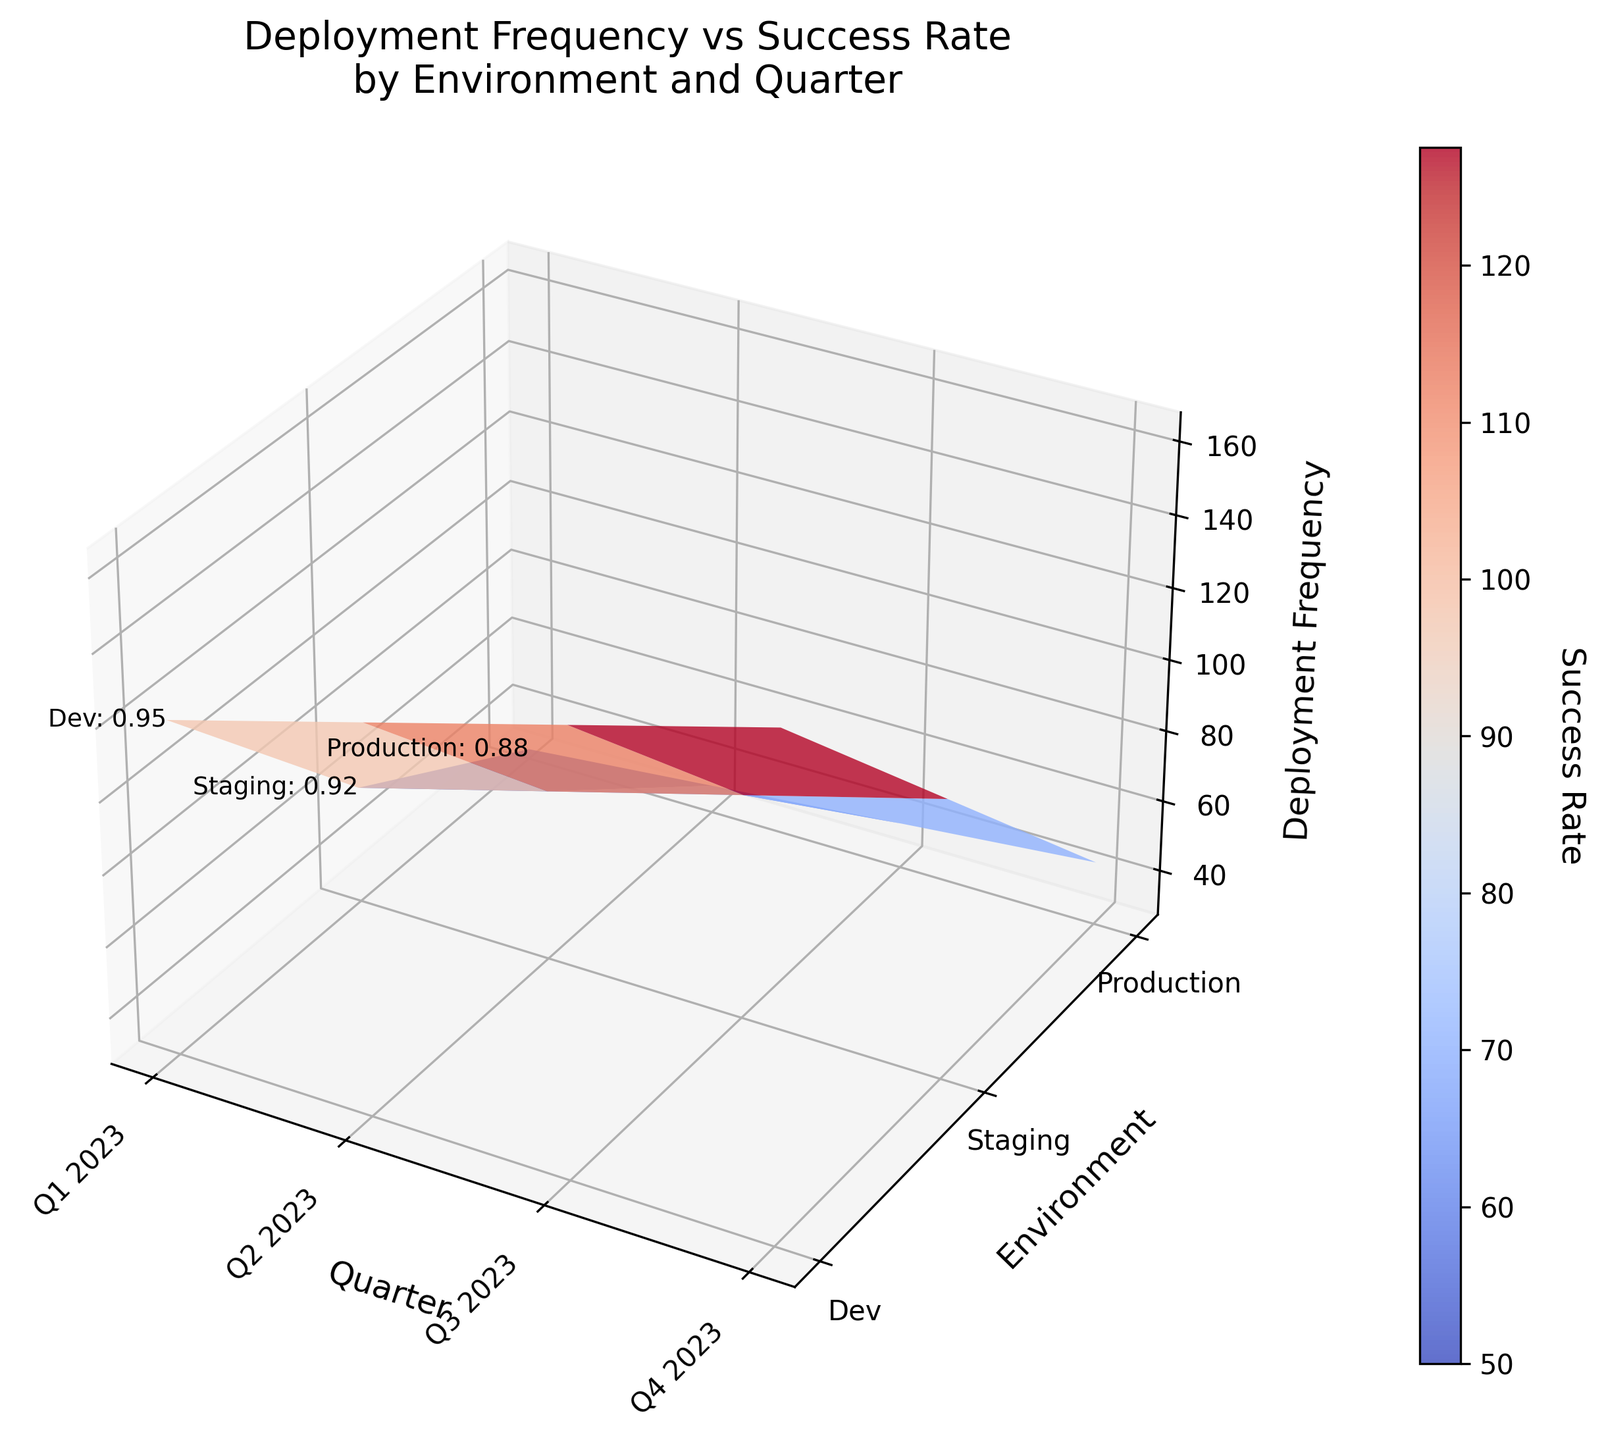What's the title of the figure? The title is typically located at the top of the figure. It gives a brief description of what the plot represents, and for this figure, it is "Deployment Frequency vs Success Rate by Environment and Quarter".
Answer: Deployment Frequency vs Success Rate by Environment and Quarter What are the axes labels in this plot? Axes labels provide information about the variables each axis represents. From the figure, the x-axis is labeled "Quarter", the y-axis is labeled "Environment", and the z-axis is labeled "Deployment Frequency".
Answer: Quarter, Environment, Deployment Frequency What is the deployment frequency in the production environment for Q3 2023? To find the deployment frequency for Q3 2023 in the production environment, locate the point on the z-axis that corresponds to the production environment on the y-axis and Q3 2023 on the x-axis. The value on the z-axis (height) provides the deployment frequency. In this case, it is 40.
Answer: 40 Which environment shows the highest success rate in Q4 2023, and what is that rate? By examining the color gradient or annotation on the plot at Q4 2023 across different environments, we see that the dev environment shows the highest success rate of 0.98.
Answer: Dev, 0.98 Compare the deployment frequency trend over quarters for the dev environment. What do you observe? To compare trends, analyze how the deployment frequency in the dev environment changes across different quarters (Q1 to Q4 2023). The deployment frequency steadily increases from 120 in Q1 2023 to 165 in Q4 2023, showing consistent growth.
Answer: Increasing trend What is the average success rate across all environments for Q1 2023? Determine the success rates for all environments in Q1 2023: 0.95 (Dev), 0.92 (Staging), and 0.88 (Production). Calculate the average by summing these values and dividing by the number of environments (3). The average is (0.95 + 0.92 + 0.88) / 3 = 0.917.
Answer: 0.917 How does the success rate in the staging environment for Q2 2023 compare to the dev environment for the same quarter? Observe the success rates for both environments in Q2 2023: 0.96 for Dev and 0.93 for Staging. Comparing these, the dev environment has a higher success rate.
Answer: Dev is higher Which environment has the steepest increase in deployment frequency from Q1 2023 to Q4 2023, and what is the difference in values? To identify the steepest increase, subtract the Q1 2023 frequency from the Q4 2023 frequency for each environment. The increases are: Dev (45), Staging (45), and Production (15). Both Dev and Staging have the steepest increase of 45.
Answer: Dev and Staging, 45 each Is there any environment where the success rate remains constant over the quarters? By examining the success rate values for each environment across all quarters, it can be seen that there isn't an environment where the success rate remains completely constant; all environments show some level of increase.
Answer: No 